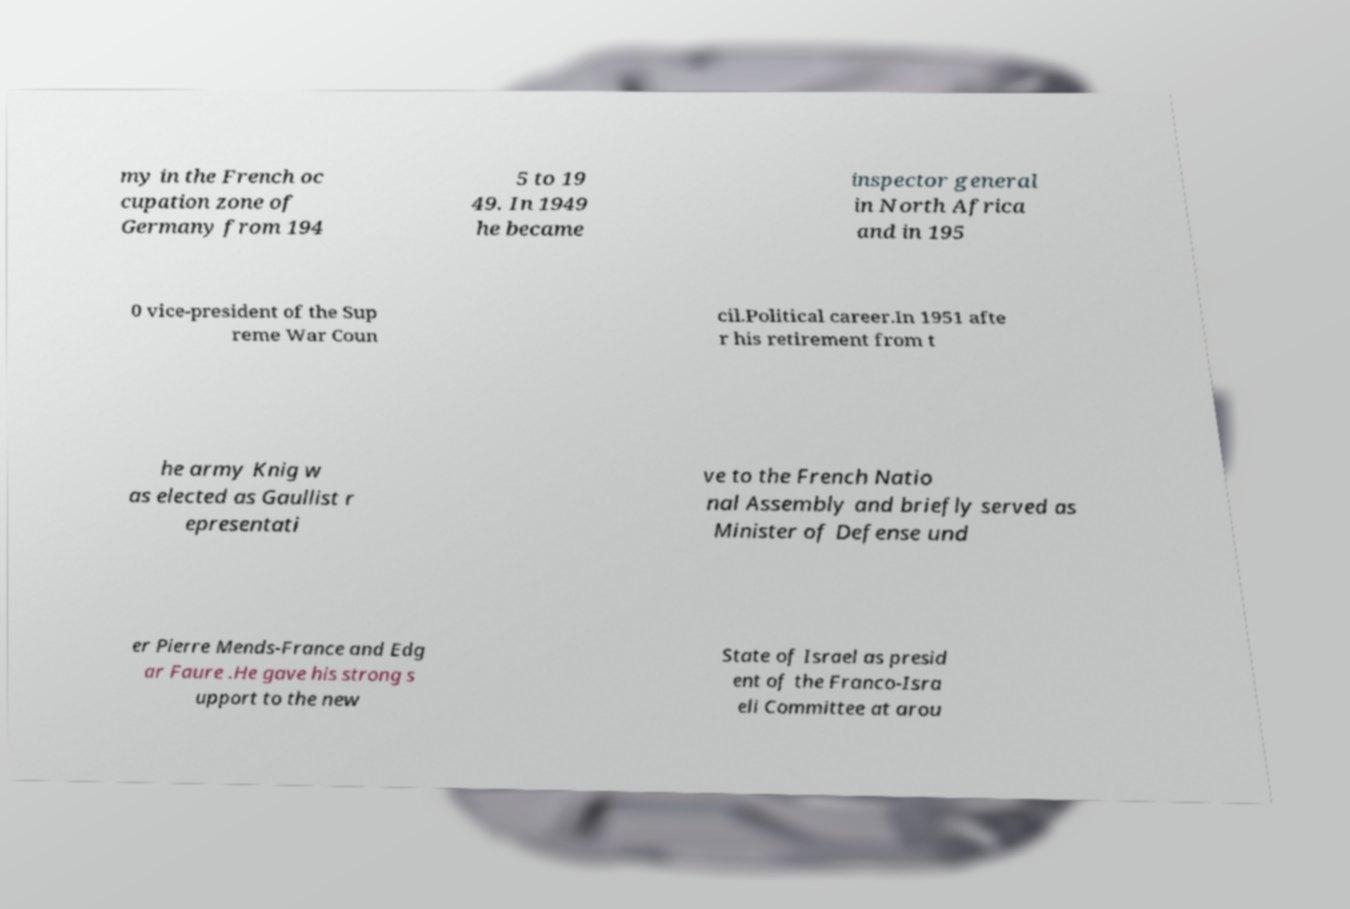There's text embedded in this image that I need extracted. Can you transcribe it verbatim? my in the French oc cupation zone of Germany from 194 5 to 19 49. In 1949 he became inspector general in North Africa and in 195 0 vice-president of the Sup reme War Coun cil.Political career.In 1951 afte r his retirement from t he army Knig w as elected as Gaullist r epresentati ve to the French Natio nal Assembly and briefly served as Minister of Defense und er Pierre Mends-France and Edg ar Faure .He gave his strong s upport to the new State of Israel as presid ent of the Franco-Isra eli Committee at arou 